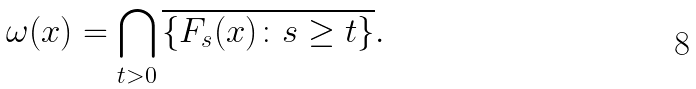<formula> <loc_0><loc_0><loc_500><loc_500>\omega ( x ) = \bigcap _ { t > 0 } \overline { \{ F _ { s } ( x ) \colon s \geq t \} } .</formula> 